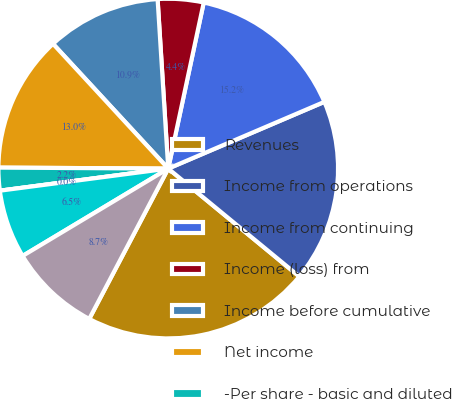<chart> <loc_0><loc_0><loc_500><loc_500><pie_chart><fcel>Revenues<fcel>Income from operations<fcel>Income from continuing<fcel>Income (loss) from<fcel>Income before cumulative<fcel>Net income<fcel>-Per share - basic and diluted<fcel>Dividends paid per share<fcel>-Low<fcel>-High<nl><fcel>21.74%<fcel>17.39%<fcel>15.22%<fcel>4.35%<fcel>10.87%<fcel>13.04%<fcel>2.17%<fcel>0.0%<fcel>6.52%<fcel>8.7%<nl></chart> 